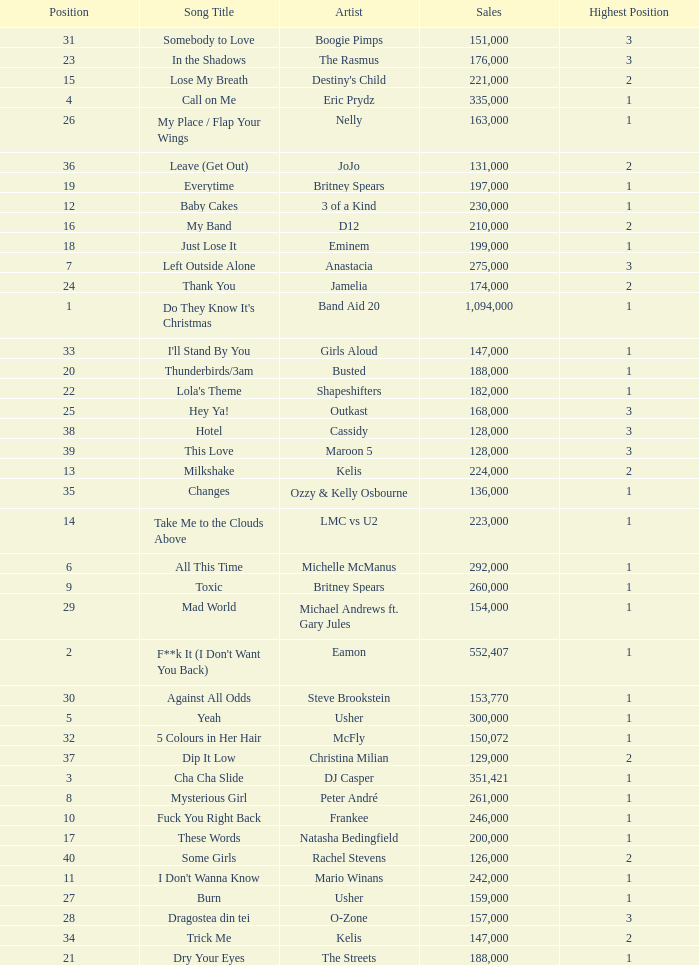What were the sales for Dj Casper when he was in a position lower than 13? 351421.0. 